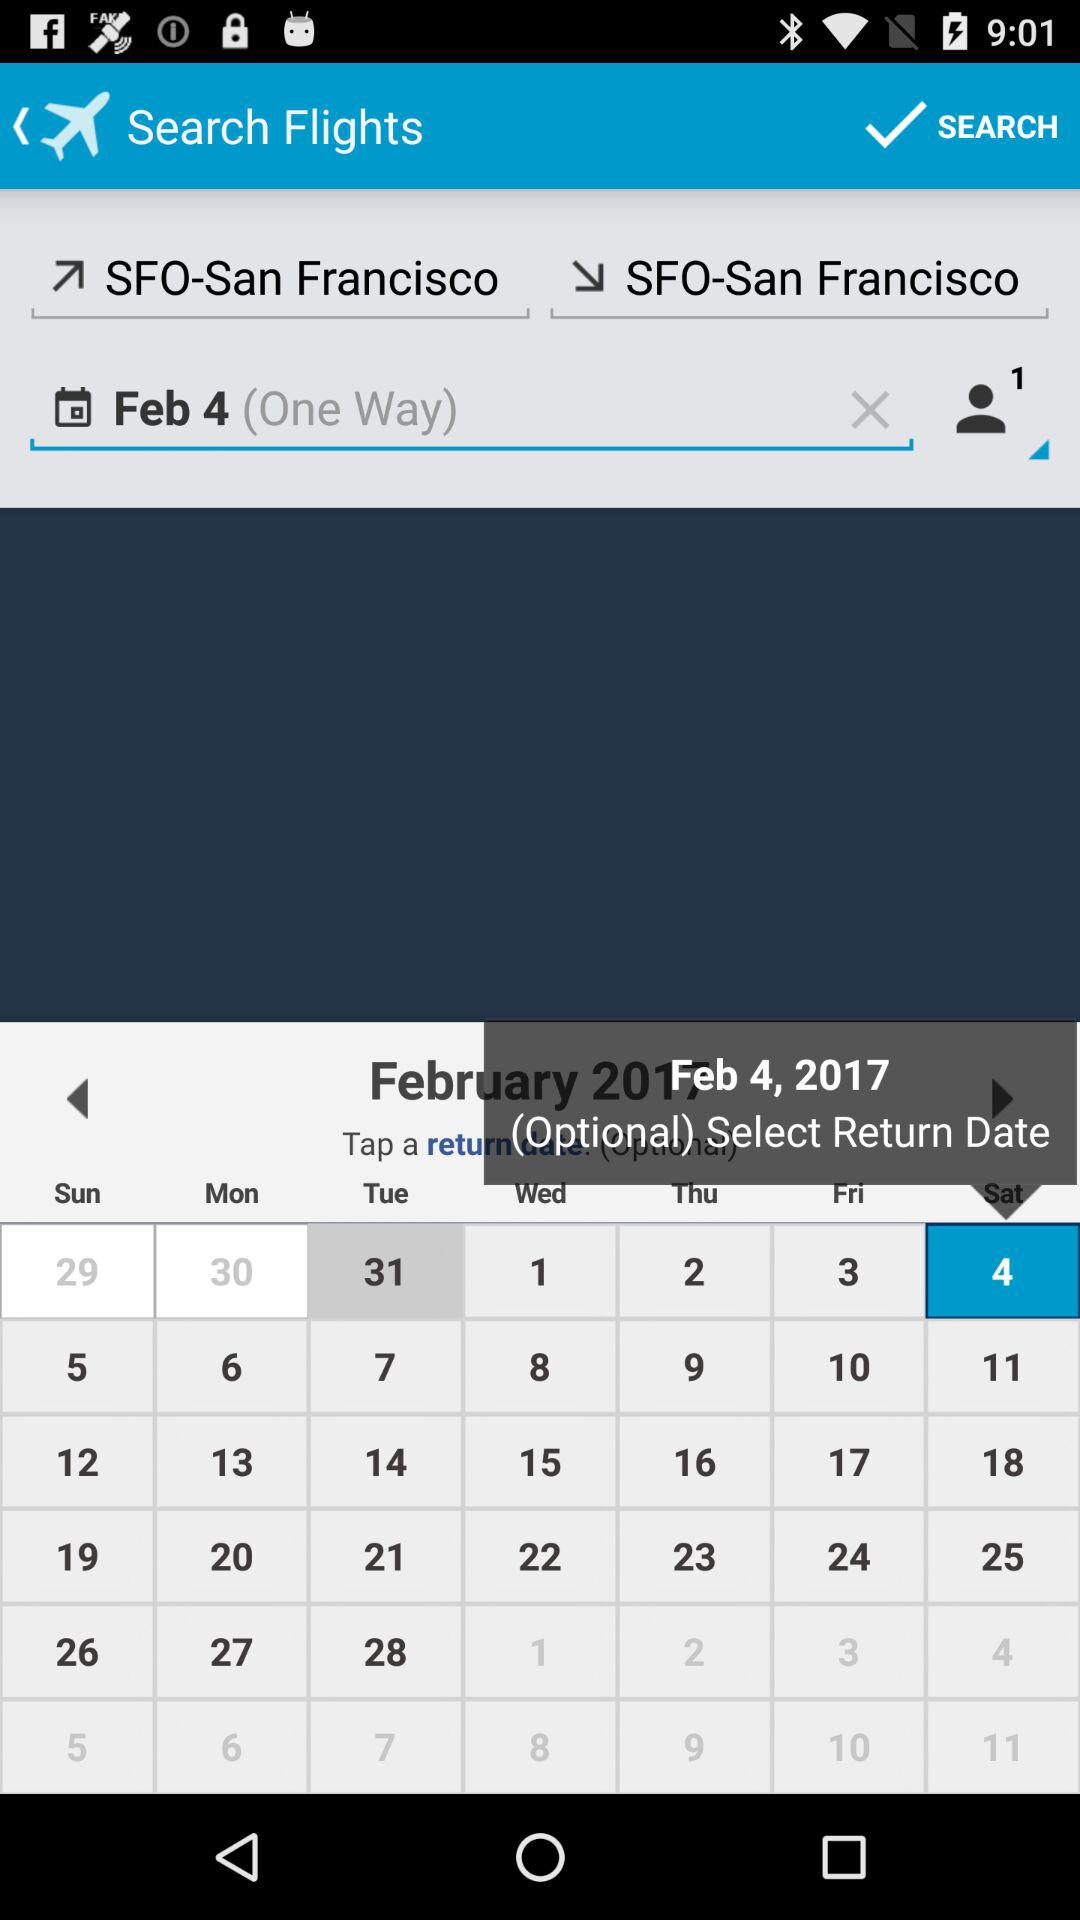What is the return date of journey?
When the provided information is insufficient, respond with <no answer>. <no answer> 